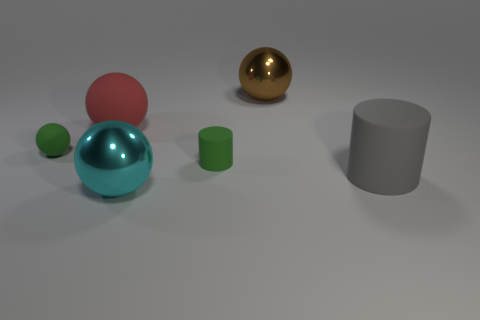What materials do the objects in the image seem to be made of? The objects exhibit different textures and reflections, suggesting they could be made of various materials: the shiny brown sphere might be a polished wood or metal, the reflective aqua object has the appearance of glass or smooth ceramic, and the matte cylinders appear to be plastic or coated metal. 